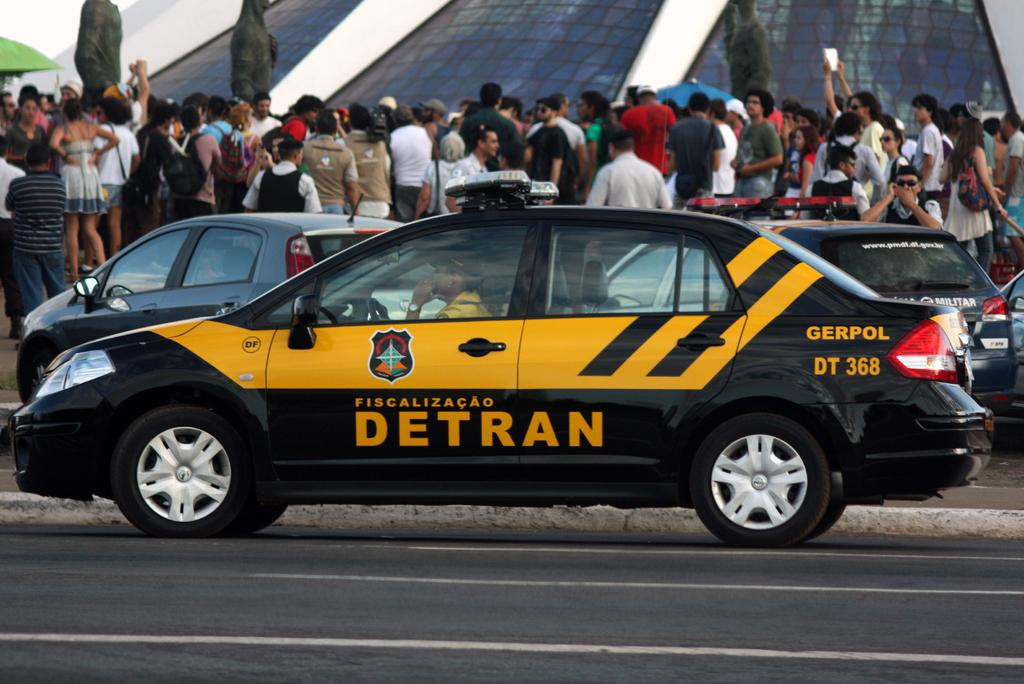<image>
Share a concise interpretation of the image provided. A black/yellow car with the sign DETRAN on the door. 